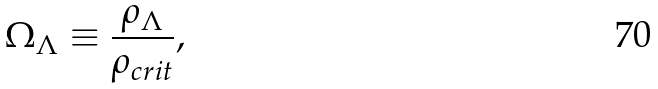<formula> <loc_0><loc_0><loc_500><loc_500>\Omega _ { \Lambda } \equiv \frac { \rho _ { \Lambda } } { \rho _ { c r i t } } ,</formula> 